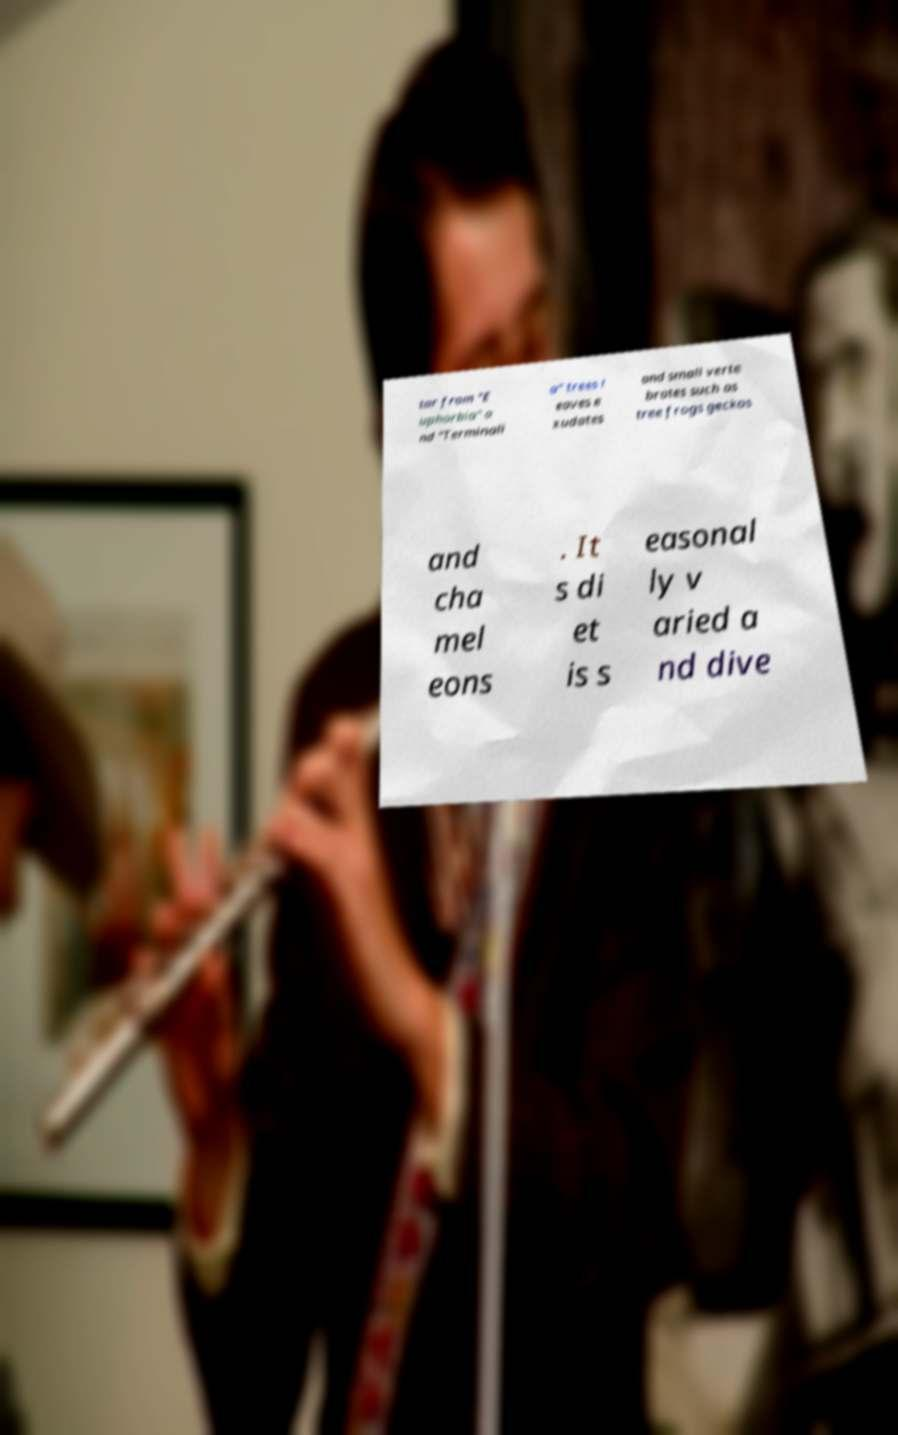What messages or text are displayed in this image? I need them in a readable, typed format. tar from "E uphorbia" a nd "Terminali a" trees l eaves e xudates and small verte brates such as tree frogs geckos and cha mel eons . It s di et is s easonal ly v aried a nd dive 